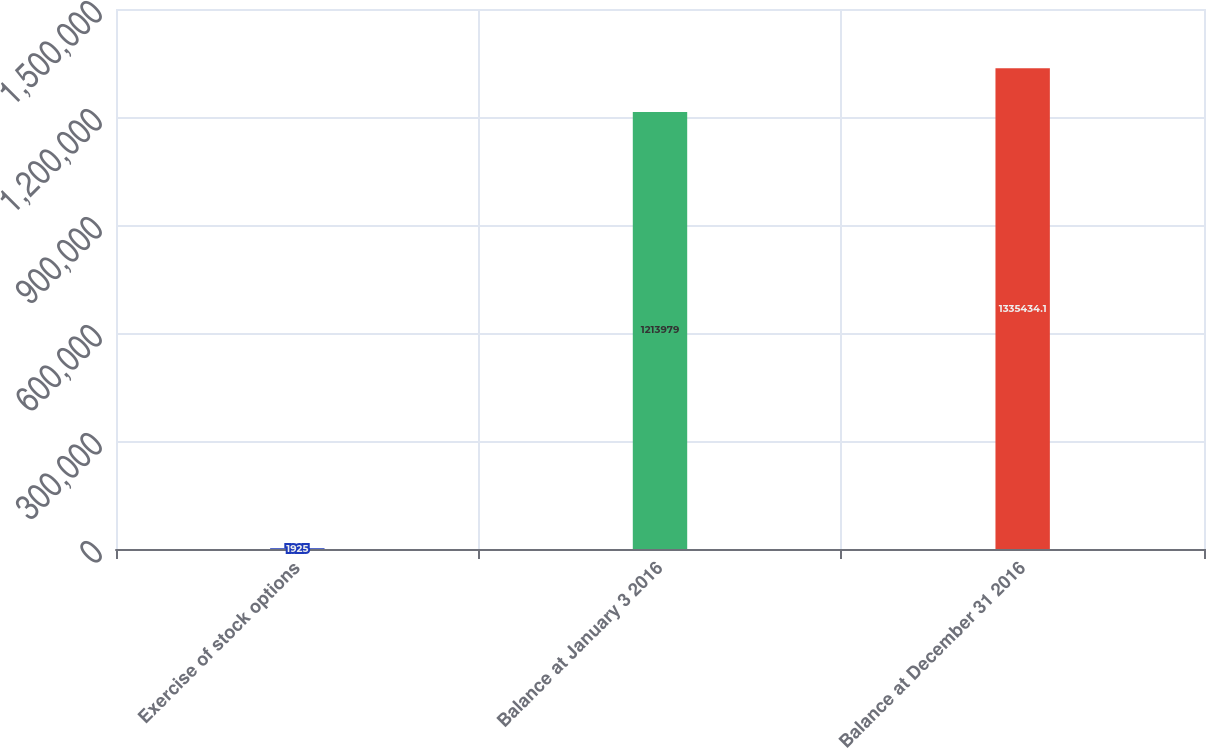Convert chart. <chart><loc_0><loc_0><loc_500><loc_500><bar_chart><fcel>Exercise of stock options<fcel>Balance at January 3 2016<fcel>Balance at December 31 2016<nl><fcel>1925<fcel>1.21398e+06<fcel>1.33543e+06<nl></chart> 